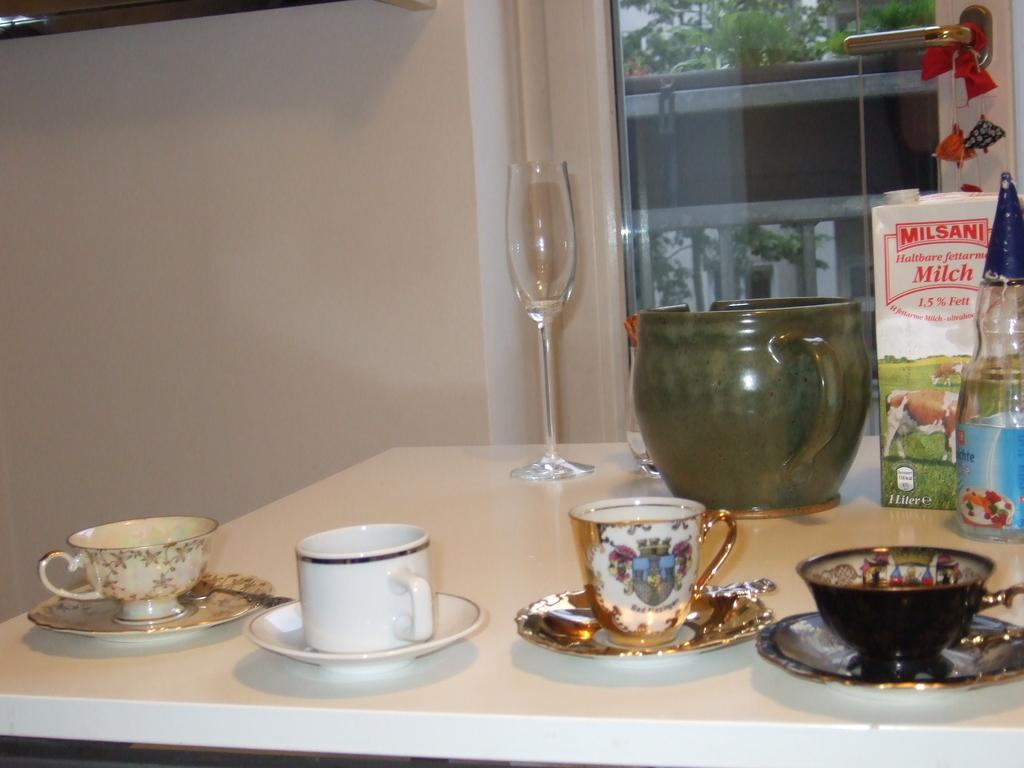What type of furniture is present in the image? There is a table in the image. What items are placed on the table? There are cups and saucers, a milk tetra pack, and a wine glass on the table. How many sisters are sitting at the table in the image? There is no information about any sisters in the image, as the facts provided only mention the table and the items on it. 